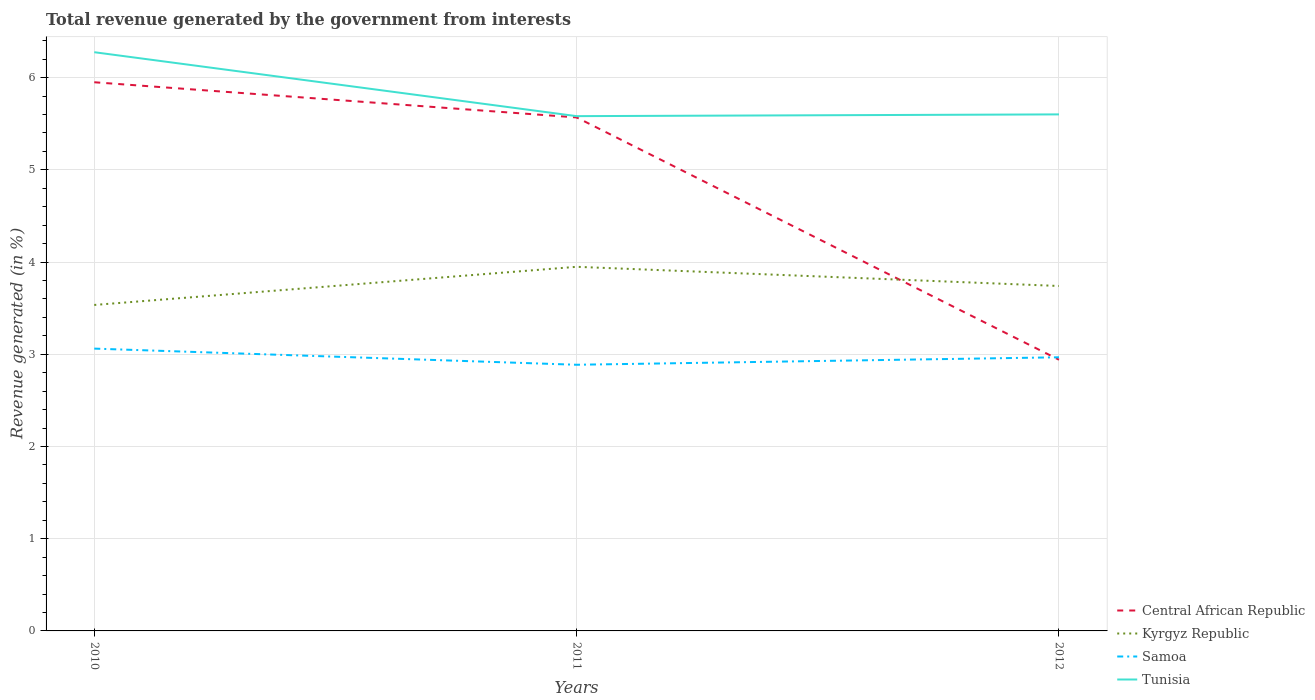Is the number of lines equal to the number of legend labels?
Provide a succinct answer. Yes. Across all years, what is the maximum total revenue generated in Tunisia?
Keep it short and to the point. 5.58. What is the total total revenue generated in Central African Republic in the graph?
Ensure brevity in your answer.  2.63. What is the difference between the highest and the second highest total revenue generated in Samoa?
Provide a short and direct response. 0.18. What is the difference between the highest and the lowest total revenue generated in Samoa?
Your answer should be very brief. 1. Is the total revenue generated in Central African Republic strictly greater than the total revenue generated in Tunisia over the years?
Provide a short and direct response. Yes. How many lines are there?
Offer a very short reply. 4. How many years are there in the graph?
Provide a succinct answer. 3. Are the values on the major ticks of Y-axis written in scientific E-notation?
Offer a very short reply. No. Does the graph contain grids?
Ensure brevity in your answer.  Yes. Where does the legend appear in the graph?
Make the answer very short. Bottom right. What is the title of the graph?
Make the answer very short. Total revenue generated by the government from interests. Does "Costa Rica" appear as one of the legend labels in the graph?
Make the answer very short. No. What is the label or title of the X-axis?
Your response must be concise. Years. What is the label or title of the Y-axis?
Ensure brevity in your answer.  Revenue generated (in %). What is the Revenue generated (in %) in Central African Republic in 2010?
Your answer should be very brief. 5.95. What is the Revenue generated (in %) of Kyrgyz Republic in 2010?
Provide a short and direct response. 3.53. What is the Revenue generated (in %) in Samoa in 2010?
Your response must be concise. 3.06. What is the Revenue generated (in %) of Tunisia in 2010?
Give a very brief answer. 6.28. What is the Revenue generated (in %) of Central African Republic in 2011?
Your answer should be very brief. 5.57. What is the Revenue generated (in %) of Kyrgyz Republic in 2011?
Your response must be concise. 3.95. What is the Revenue generated (in %) in Samoa in 2011?
Your answer should be compact. 2.89. What is the Revenue generated (in %) of Tunisia in 2011?
Your answer should be very brief. 5.58. What is the Revenue generated (in %) in Central African Republic in 2012?
Offer a terse response. 2.94. What is the Revenue generated (in %) in Kyrgyz Republic in 2012?
Your response must be concise. 3.74. What is the Revenue generated (in %) in Samoa in 2012?
Provide a short and direct response. 2.97. What is the Revenue generated (in %) in Tunisia in 2012?
Your answer should be compact. 5.6. Across all years, what is the maximum Revenue generated (in %) of Central African Republic?
Offer a very short reply. 5.95. Across all years, what is the maximum Revenue generated (in %) of Kyrgyz Republic?
Your answer should be very brief. 3.95. Across all years, what is the maximum Revenue generated (in %) of Samoa?
Provide a succinct answer. 3.06. Across all years, what is the maximum Revenue generated (in %) in Tunisia?
Your answer should be very brief. 6.28. Across all years, what is the minimum Revenue generated (in %) of Central African Republic?
Offer a very short reply. 2.94. Across all years, what is the minimum Revenue generated (in %) in Kyrgyz Republic?
Offer a terse response. 3.53. Across all years, what is the minimum Revenue generated (in %) of Samoa?
Offer a terse response. 2.89. Across all years, what is the minimum Revenue generated (in %) in Tunisia?
Keep it short and to the point. 5.58. What is the total Revenue generated (in %) of Central African Republic in the graph?
Offer a terse response. 14.46. What is the total Revenue generated (in %) in Kyrgyz Republic in the graph?
Offer a terse response. 11.22. What is the total Revenue generated (in %) in Samoa in the graph?
Give a very brief answer. 8.92. What is the total Revenue generated (in %) of Tunisia in the graph?
Your response must be concise. 17.46. What is the difference between the Revenue generated (in %) in Central African Republic in 2010 and that in 2011?
Provide a succinct answer. 0.38. What is the difference between the Revenue generated (in %) of Kyrgyz Republic in 2010 and that in 2011?
Provide a short and direct response. -0.41. What is the difference between the Revenue generated (in %) of Samoa in 2010 and that in 2011?
Your answer should be compact. 0.18. What is the difference between the Revenue generated (in %) of Tunisia in 2010 and that in 2011?
Make the answer very short. 0.69. What is the difference between the Revenue generated (in %) of Central African Republic in 2010 and that in 2012?
Offer a very short reply. 3.01. What is the difference between the Revenue generated (in %) in Kyrgyz Republic in 2010 and that in 2012?
Provide a succinct answer. -0.21. What is the difference between the Revenue generated (in %) of Samoa in 2010 and that in 2012?
Your answer should be compact. 0.09. What is the difference between the Revenue generated (in %) in Tunisia in 2010 and that in 2012?
Your answer should be compact. 0.67. What is the difference between the Revenue generated (in %) of Central African Republic in 2011 and that in 2012?
Offer a very short reply. 2.63. What is the difference between the Revenue generated (in %) of Kyrgyz Republic in 2011 and that in 2012?
Offer a terse response. 0.21. What is the difference between the Revenue generated (in %) of Samoa in 2011 and that in 2012?
Your answer should be compact. -0.08. What is the difference between the Revenue generated (in %) in Tunisia in 2011 and that in 2012?
Make the answer very short. -0.02. What is the difference between the Revenue generated (in %) in Central African Republic in 2010 and the Revenue generated (in %) in Kyrgyz Republic in 2011?
Your answer should be very brief. 2. What is the difference between the Revenue generated (in %) in Central African Republic in 2010 and the Revenue generated (in %) in Samoa in 2011?
Provide a short and direct response. 3.06. What is the difference between the Revenue generated (in %) in Central African Republic in 2010 and the Revenue generated (in %) in Tunisia in 2011?
Your response must be concise. 0.37. What is the difference between the Revenue generated (in %) in Kyrgyz Republic in 2010 and the Revenue generated (in %) in Samoa in 2011?
Provide a short and direct response. 0.65. What is the difference between the Revenue generated (in %) in Kyrgyz Republic in 2010 and the Revenue generated (in %) in Tunisia in 2011?
Offer a very short reply. -2.05. What is the difference between the Revenue generated (in %) of Samoa in 2010 and the Revenue generated (in %) of Tunisia in 2011?
Offer a very short reply. -2.52. What is the difference between the Revenue generated (in %) of Central African Republic in 2010 and the Revenue generated (in %) of Kyrgyz Republic in 2012?
Give a very brief answer. 2.21. What is the difference between the Revenue generated (in %) in Central African Republic in 2010 and the Revenue generated (in %) in Samoa in 2012?
Your answer should be compact. 2.98. What is the difference between the Revenue generated (in %) of Central African Republic in 2010 and the Revenue generated (in %) of Tunisia in 2012?
Your answer should be compact. 0.35. What is the difference between the Revenue generated (in %) of Kyrgyz Republic in 2010 and the Revenue generated (in %) of Samoa in 2012?
Provide a short and direct response. 0.57. What is the difference between the Revenue generated (in %) in Kyrgyz Republic in 2010 and the Revenue generated (in %) in Tunisia in 2012?
Your answer should be very brief. -2.07. What is the difference between the Revenue generated (in %) in Samoa in 2010 and the Revenue generated (in %) in Tunisia in 2012?
Provide a succinct answer. -2.54. What is the difference between the Revenue generated (in %) of Central African Republic in 2011 and the Revenue generated (in %) of Kyrgyz Republic in 2012?
Offer a terse response. 1.83. What is the difference between the Revenue generated (in %) of Central African Republic in 2011 and the Revenue generated (in %) of Samoa in 2012?
Make the answer very short. 2.6. What is the difference between the Revenue generated (in %) in Central African Republic in 2011 and the Revenue generated (in %) in Tunisia in 2012?
Your response must be concise. -0.03. What is the difference between the Revenue generated (in %) in Kyrgyz Republic in 2011 and the Revenue generated (in %) in Samoa in 2012?
Your answer should be compact. 0.98. What is the difference between the Revenue generated (in %) of Kyrgyz Republic in 2011 and the Revenue generated (in %) of Tunisia in 2012?
Provide a succinct answer. -1.65. What is the difference between the Revenue generated (in %) of Samoa in 2011 and the Revenue generated (in %) of Tunisia in 2012?
Your response must be concise. -2.72. What is the average Revenue generated (in %) in Central African Republic per year?
Your answer should be compact. 4.82. What is the average Revenue generated (in %) in Kyrgyz Republic per year?
Offer a terse response. 3.74. What is the average Revenue generated (in %) of Samoa per year?
Offer a very short reply. 2.97. What is the average Revenue generated (in %) in Tunisia per year?
Provide a short and direct response. 5.82. In the year 2010, what is the difference between the Revenue generated (in %) in Central African Republic and Revenue generated (in %) in Kyrgyz Republic?
Make the answer very short. 2.42. In the year 2010, what is the difference between the Revenue generated (in %) of Central African Republic and Revenue generated (in %) of Samoa?
Make the answer very short. 2.89. In the year 2010, what is the difference between the Revenue generated (in %) of Central African Republic and Revenue generated (in %) of Tunisia?
Give a very brief answer. -0.33. In the year 2010, what is the difference between the Revenue generated (in %) of Kyrgyz Republic and Revenue generated (in %) of Samoa?
Your answer should be compact. 0.47. In the year 2010, what is the difference between the Revenue generated (in %) in Kyrgyz Republic and Revenue generated (in %) in Tunisia?
Offer a terse response. -2.74. In the year 2010, what is the difference between the Revenue generated (in %) in Samoa and Revenue generated (in %) in Tunisia?
Offer a very short reply. -3.21. In the year 2011, what is the difference between the Revenue generated (in %) of Central African Republic and Revenue generated (in %) of Kyrgyz Republic?
Ensure brevity in your answer.  1.62. In the year 2011, what is the difference between the Revenue generated (in %) of Central African Republic and Revenue generated (in %) of Samoa?
Your response must be concise. 2.68. In the year 2011, what is the difference between the Revenue generated (in %) of Central African Republic and Revenue generated (in %) of Tunisia?
Offer a terse response. -0.01. In the year 2011, what is the difference between the Revenue generated (in %) in Kyrgyz Republic and Revenue generated (in %) in Samoa?
Keep it short and to the point. 1.06. In the year 2011, what is the difference between the Revenue generated (in %) of Kyrgyz Republic and Revenue generated (in %) of Tunisia?
Offer a very short reply. -1.63. In the year 2011, what is the difference between the Revenue generated (in %) of Samoa and Revenue generated (in %) of Tunisia?
Your answer should be very brief. -2.7. In the year 2012, what is the difference between the Revenue generated (in %) of Central African Republic and Revenue generated (in %) of Kyrgyz Republic?
Your response must be concise. -0.8. In the year 2012, what is the difference between the Revenue generated (in %) in Central African Republic and Revenue generated (in %) in Samoa?
Your answer should be compact. -0.03. In the year 2012, what is the difference between the Revenue generated (in %) in Central African Republic and Revenue generated (in %) in Tunisia?
Provide a short and direct response. -2.66. In the year 2012, what is the difference between the Revenue generated (in %) of Kyrgyz Republic and Revenue generated (in %) of Samoa?
Offer a terse response. 0.77. In the year 2012, what is the difference between the Revenue generated (in %) of Kyrgyz Republic and Revenue generated (in %) of Tunisia?
Offer a very short reply. -1.86. In the year 2012, what is the difference between the Revenue generated (in %) of Samoa and Revenue generated (in %) of Tunisia?
Your answer should be compact. -2.63. What is the ratio of the Revenue generated (in %) of Central African Republic in 2010 to that in 2011?
Keep it short and to the point. 1.07. What is the ratio of the Revenue generated (in %) of Kyrgyz Republic in 2010 to that in 2011?
Provide a succinct answer. 0.9. What is the ratio of the Revenue generated (in %) in Samoa in 2010 to that in 2011?
Provide a succinct answer. 1.06. What is the ratio of the Revenue generated (in %) in Tunisia in 2010 to that in 2011?
Your answer should be compact. 1.12. What is the ratio of the Revenue generated (in %) in Central African Republic in 2010 to that in 2012?
Keep it short and to the point. 2.02. What is the ratio of the Revenue generated (in %) in Kyrgyz Republic in 2010 to that in 2012?
Your answer should be compact. 0.94. What is the ratio of the Revenue generated (in %) in Samoa in 2010 to that in 2012?
Provide a short and direct response. 1.03. What is the ratio of the Revenue generated (in %) in Tunisia in 2010 to that in 2012?
Your answer should be compact. 1.12. What is the ratio of the Revenue generated (in %) of Central African Republic in 2011 to that in 2012?
Your response must be concise. 1.89. What is the ratio of the Revenue generated (in %) in Kyrgyz Republic in 2011 to that in 2012?
Your response must be concise. 1.06. What is the ratio of the Revenue generated (in %) of Samoa in 2011 to that in 2012?
Keep it short and to the point. 0.97. What is the ratio of the Revenue generated (in %) in Tunisia in 2011 to that in 2012?
Your answer should be compact. 1. What is the difference between the highest and the second highest Revenue generated (in %) of Central African Republic?
Ensure brevity in your answer.  0.38. What is the difference between the highest and the second highest Revenue generated (in %) of Kyrgyz Republic?
Ensure brevity in your answer.  0.21. What is the difference between the highest and the second highest Revenue generated (in %) of Samoa?
Keep it short and to the point. 0.09. What is the difference between the highest and the second highest Revenue generated (in %) of Tunisia?
Your answer should be very brief. 0.67. What is the difference between the highest and the lowest Revenue generated (in %) in Central African Republic?
Your answer should be very brief. 3.01. What is the difference between the highest and the lowest Revenue generated (in %) in Kyrgyz Republic?
Offer a terse response. 0.41. What is the difference between the highest and the lowest Revenue generated (in %) of Samoa?
Give a very brief answer. 0.18. What is the difference between the highest and the lowest Revenue generated (in %) of Tunisia?
Your response must be concise. 0.69. 